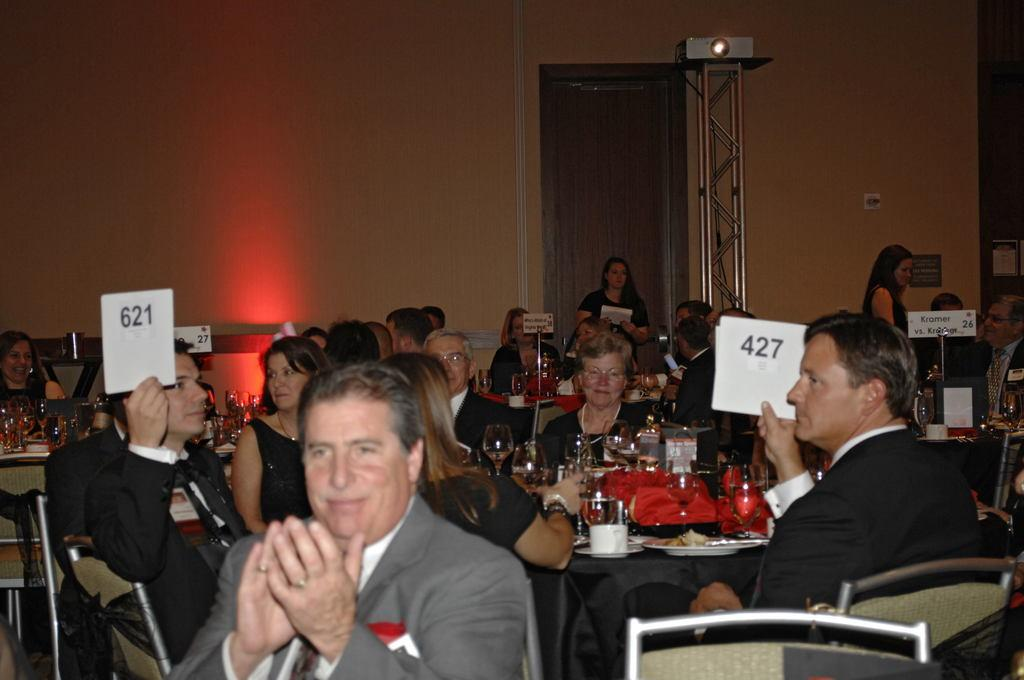What are the people in the image doing? There is a group of persons sitting on chairs in the image. What is in front of the chairs? There is a table in front of the chairs. What can be seen on the table? There are glasses on the table, as well as other objects. What is visible in the background of the image? There is a wall visible in the image. What type of bomb is present on the table in the image? There is no bomb present on the table or in the image. What kind of food is being served on the table in the image? The provided facts do not mention any food on the table, only glasses and other objects. 